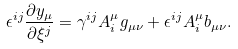Convert formula to latex. <formula><loc_0><loc_0><loc_500><loc_500>\epsilon ^ { i j } \frac { \partial y _ { \mu } } { \partial \xi ^ { j } } = \gamma ^ { i j } A _ { i } ^ { \mu } g _ { \mu \nu } + \epsilon ^ { i j } A _ { i } ^ { \mu } b _ { \mu \nu } .</formula> 